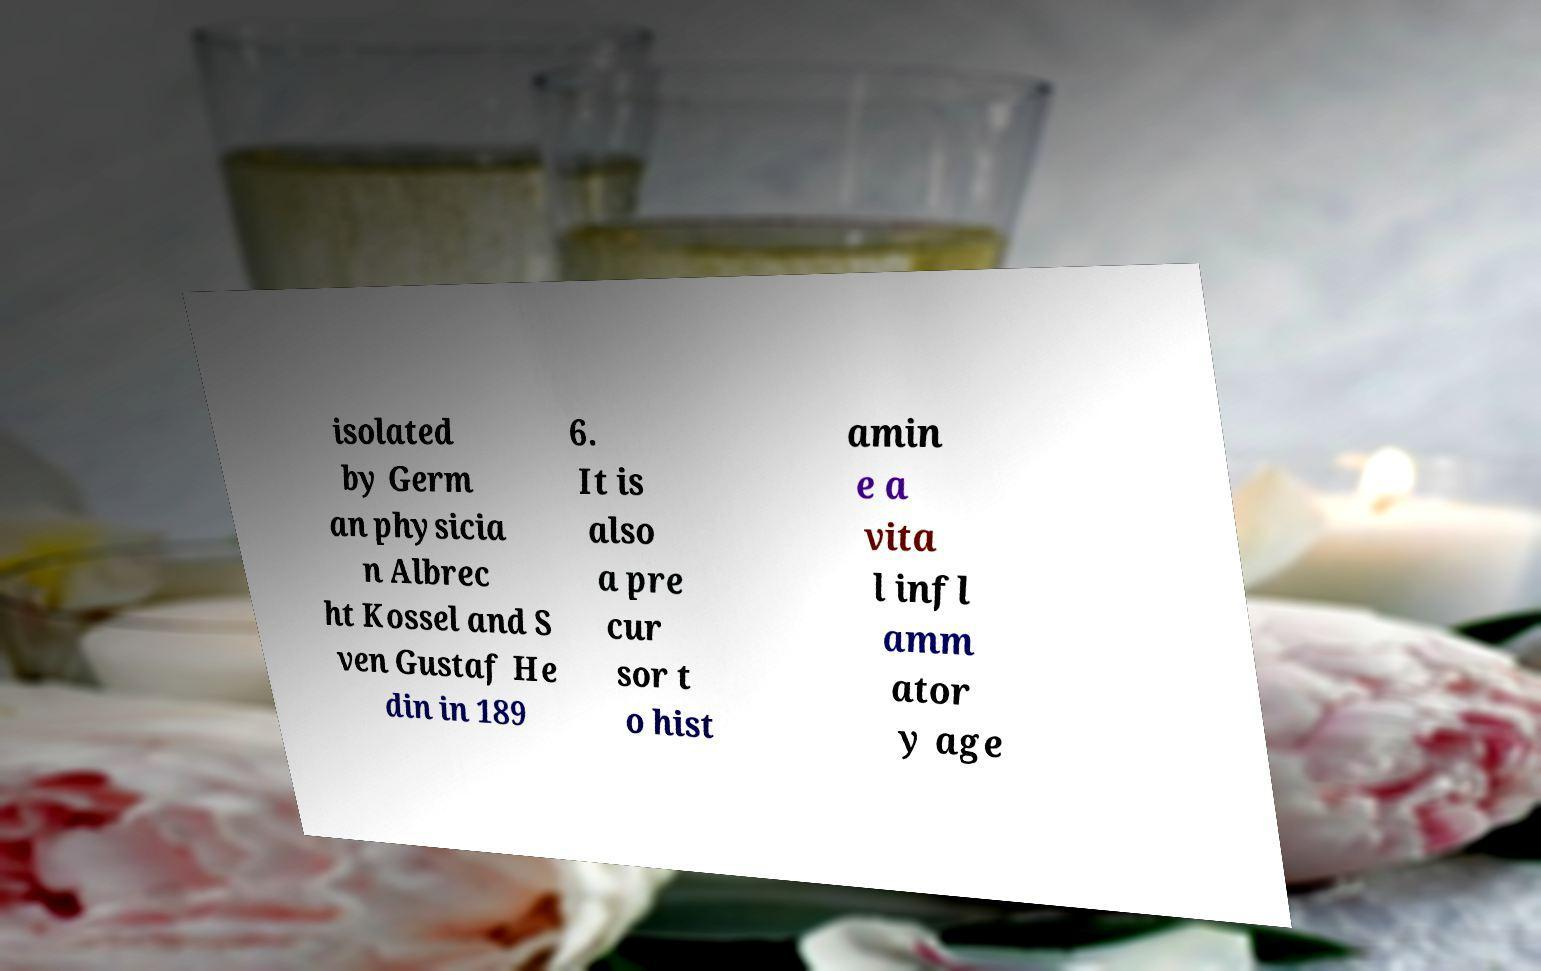Can you read and provide the text displayed in the image?This photo seems to have some interesting text. Can you extract and type it out for me? isolated by Germ an physicia n Albrec ht Kossel and S ven Gustaf He din in 189 6. It is also a pre cur sor t o hist amin e a vita l infl amm ator y age 